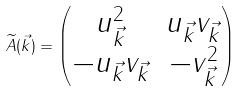<formula> <loc_0><loc_0><loc_500><loc_500>\widetilde { A } ( \vec { k } ) = \begin{pmatrix} u _ { \vec { k } } ^ { 2 } & u _ { \vec { k } } v _ { \vec { k } } \\ - u _ { \vec { k } } v _ { \vec { k } } & - v _ { \vec { k } } ^ { 2 } \end{pmatrix}</formula> 